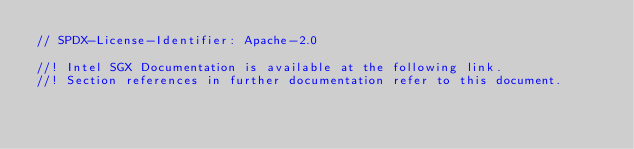Convert code to text. <code><loc_0><loc_0><loc_500><loc_500><_Rust_>// SPDX-License-Identifier: Apache-2.0

//! Intel SGX Documentation is available at the following link.
//! Section references in further documentation refer to this document.</code> 